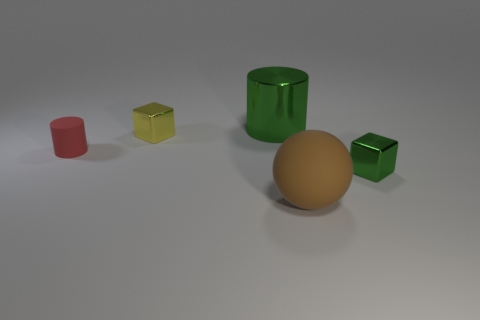Is the number of balls right of the large green cylinder the same as the number of red cylinders?
Provide a short and direct response. Yes. Are there any large balls that are left of the tiny object behind the red rubber thing?
Your answer should be compact. No. What size is the green thing behind the cylinder that is to the left of the green metal object that is left of the large matte thing?
Your response must be concise. Large. There is a tiny thing that is on the right side of the large ball in front of the red thing; what is it made of?
Provide a short and direct response. Metal. Are there any green things that have the same shape as the brown thing?
Give a very brief answer. No. The tiny rubber thing has what shape?
Offer a very short reply. Cylinder. The large thing behind the small cube in front of the rubber object on the left side of the big green cylinder is made of what material?
Provide a succinct answer. Metal. Is the number of small shiny objects left of the large shiny thing greater than the number of big blue matte objects?
Keep it short and to the point. Yes. There is a brown sphere that is the same size as the metal cylinder; what material is it?
Your response must be concise. Rubber. Are there any shiny cylinders of the same size as the red thing?
Offer a very short reply. No. 